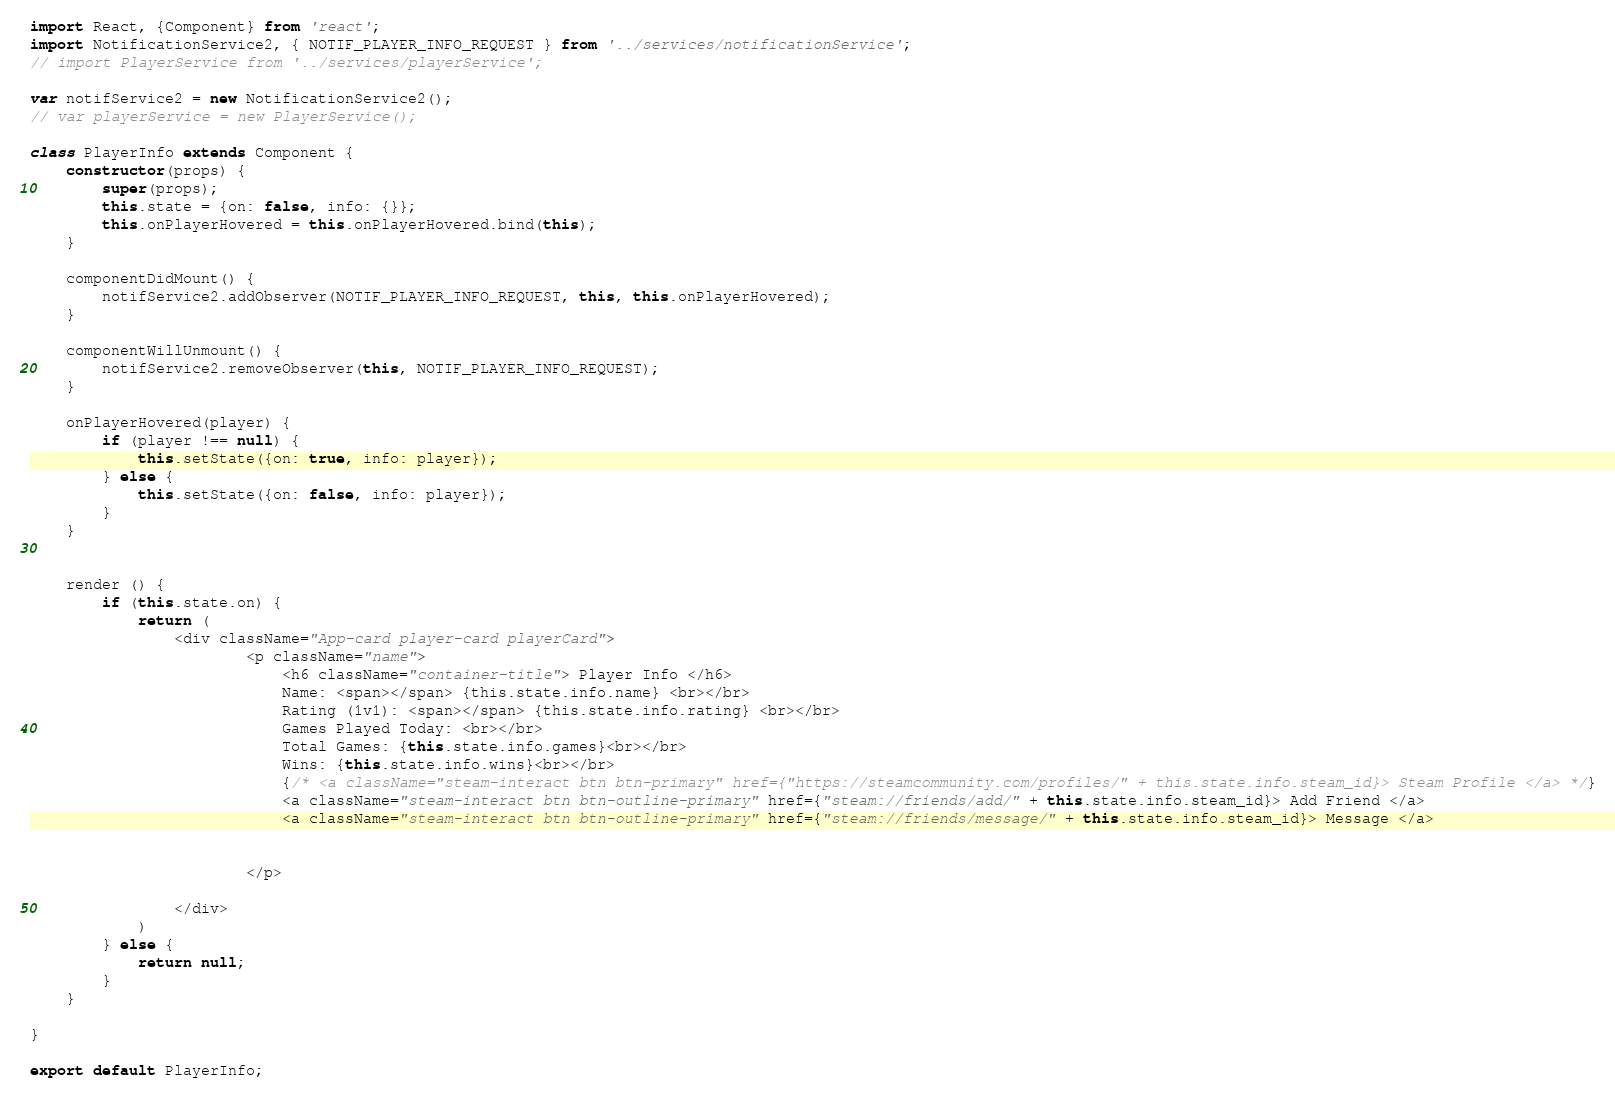<code> <loc_0><loc_0><loc_500><loc_500><_JavaScript_>import React, {Component} from 'react';
import NotificationService2, { NOTIF_PLAYER_INFO_REQUEST } from '../services/notificationService';
// import PlayerService from '../services/playerService';

var notifService2 = new NotificationService2();
// var playerService = new PlayerService();

class PlayerInfo extends Component {
    constructor(props) {
        super(props);
        this.state = {on: false, info: {}};
        this.onPlayerHovered = this.onPlayerHovered.bind(this);
    }

    componentDidMount() {
        notifService2.addObserver(NOTIF_PLAYER_INFO_REQUEST, this, this.onPlayerHovered);
    }

    componentWillUnmount() {
        notifService2.removeObserver(this, NOTIF_PLAYER_INFO_REQUEST);
    }

    onPlayerHovered(player) {
        if (player !== null) {
            this.setState({on: true, info: player});
        } else {
            this.setState({on: false, info: player});
        }
    }

    
    render () {
        if (this.state.on) {
            return (
                <div className="App-card player-card playerCard">
                        <p className="name">
                            <h6 className="container-title"> Player Info </h6>
                            Name: <span></span> {this.state.info.name} <br></br>
                            Rating (1v1): <span></span> {this.state.info.rating} <br></br>
                            Games Played Today: <br></br>
                            Total Games: {this.state.info.games}<br></br>
                            Wins: {this.state.info.wins}<br></br>
                            {/* <a className="steam-interact btn btn-primary" href={"https://steamcommunity.com/profiles/" + this.state.info.steam_id}> Steam Profile </a> */}
                            <a className="steam-interact btn btn-outline-primary" href={"steam://friends/add/" + this.state.info.steam_id}> Add Friend </a>
                            <a className="steam-interact btn btn-outline-primary" href={"steam://friends/message/" + this.state.info.steam_id}> Message </a>
                            
                        
                        </p>

                </div>
            )
        } else {
            return null;
        }
    }
    
}

export default PlayerInfo;</code> 